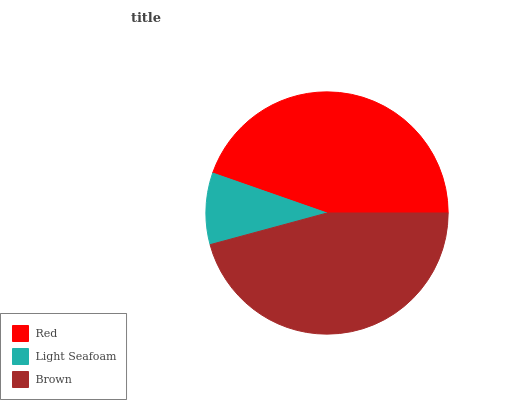Is Light Seafoam the minimum?
Answer yes or no. Yes. Is Brown the maximum?
Answer yes or no. Yes. Is Brown the minimum?
Answer yes or no. No. Is Light Seafoam the maximum?
Answer yes or no. No. Is Brown greater than Light Seafoam?
Answer yes or no. Yes. Is Light Seafoam less than Brown?
Answer yes or no. Yes. Is Light Seafoam greater than Brown?
Answer yes or no. No. Is Brown less than Light Seafoam?
Answer yes or no. No. Is Red the high median?
Answer yes or no. Yes. Is Red the low median?
Answer yes or no. Yes. Is Light Seafoam the high median?
Answer yes or no. No. Is Light Seafoam the low median?
Answer yes or no. No. 